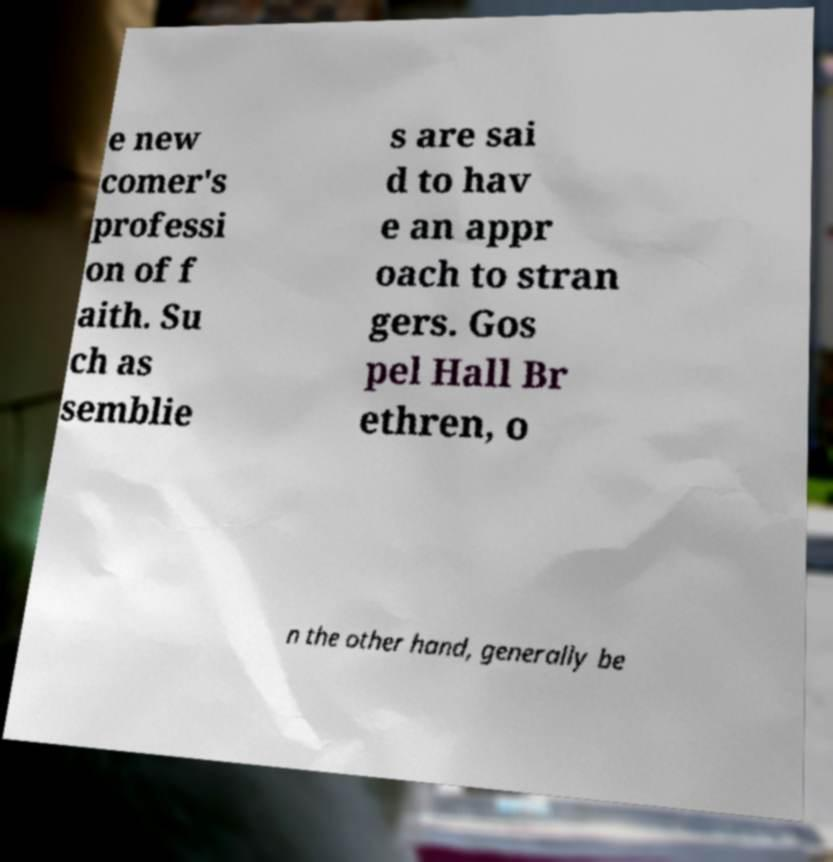I need the written content from this picture converted into text. Can you do that? e new comer's professi on of f aith. Su ch as semblie s are sai d to hav e an appr oach to stran gers. Gos pel Hall Br ethren, o n the other hand, generally be 